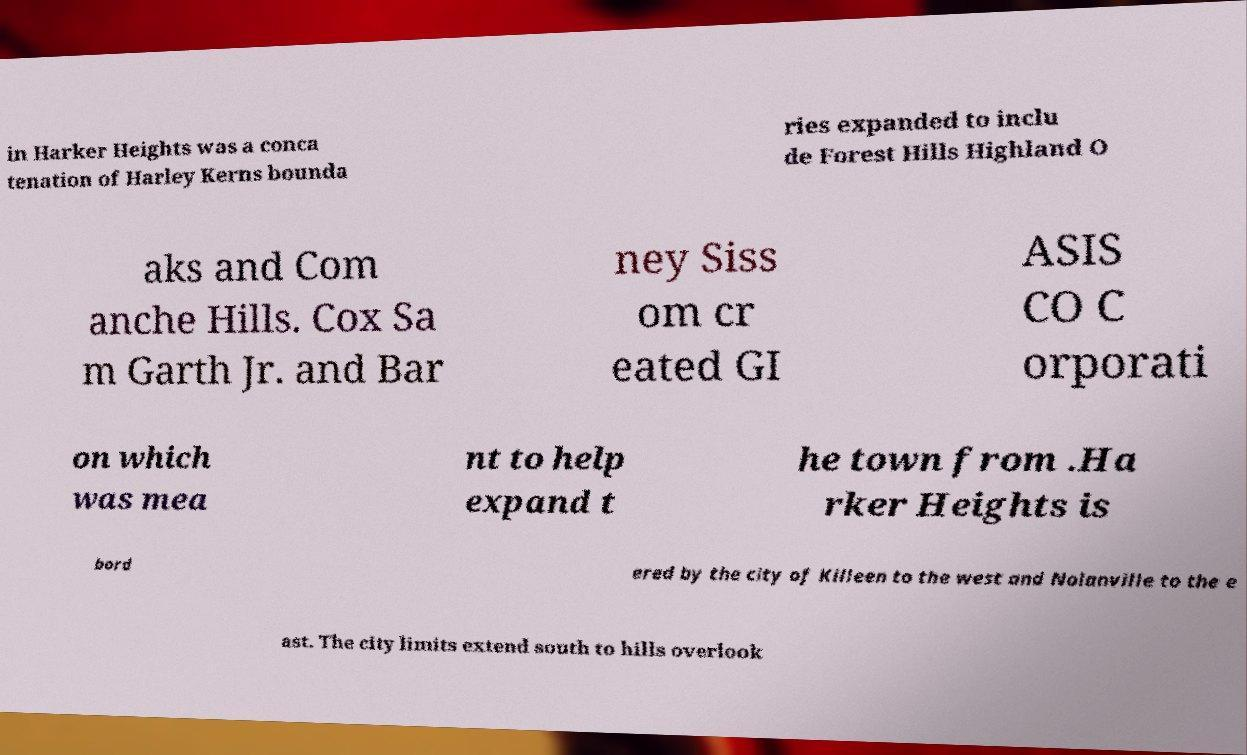Can you accurately transcribe the text from the provided image for me? in Harker Heights was a conca tenation of Harley Kerns bounda ries expanded to inclu de Forest Hills Highland O aks and Com anche Hills. Cox Sa m Garth Jr. and Bar ney Siss om cr eated GI ASIS CO C orporati on which was mea nt to help expand t he town from .Ha rker Heights is bord ered by the city of Killeen to the west and Nolanville to the e ast. The city limits extend south to hills overlook 